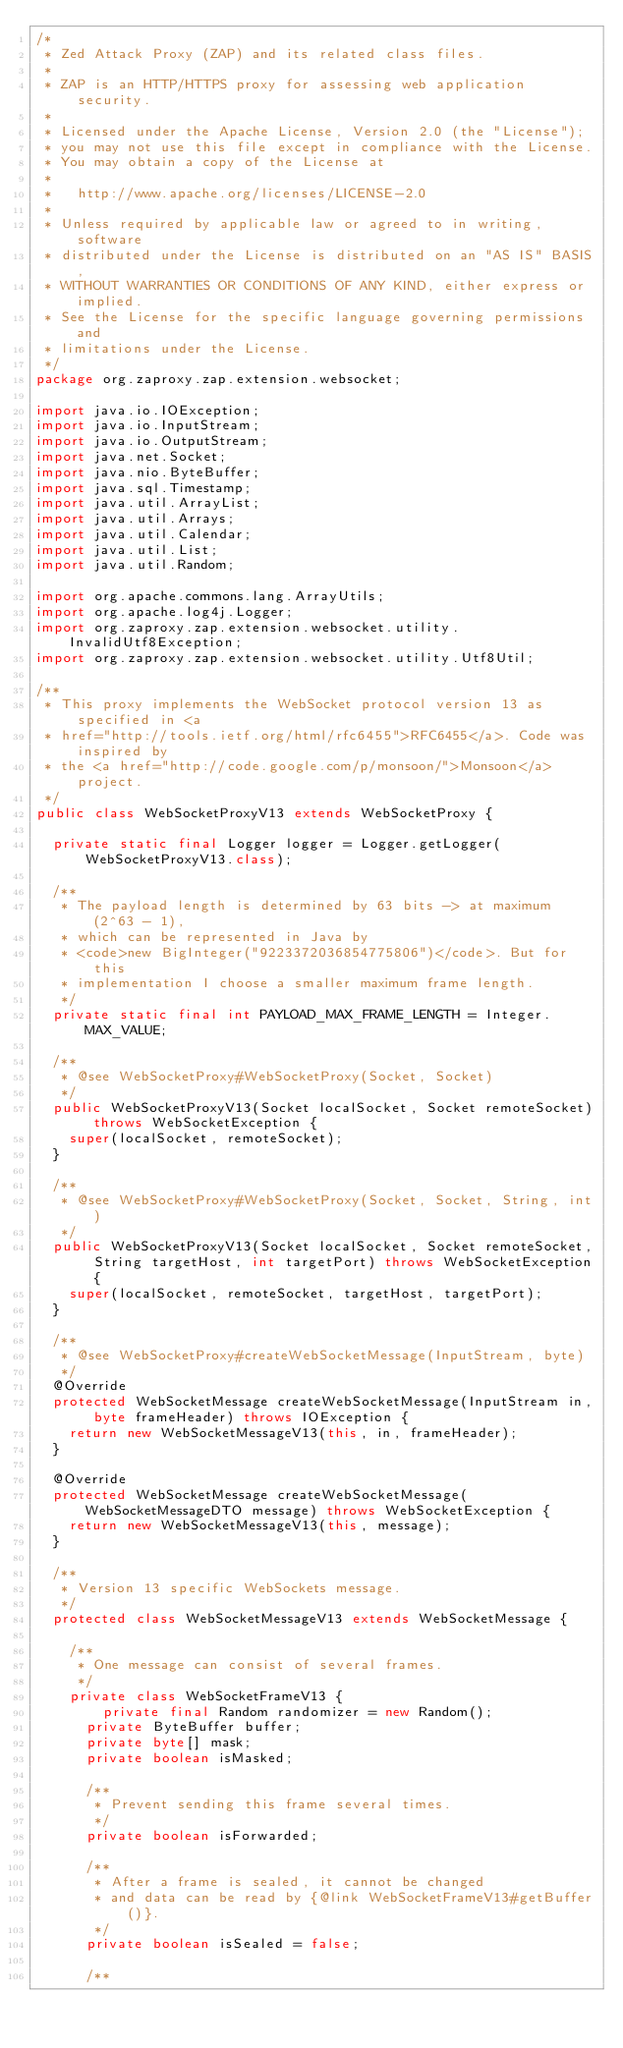Convert code to text. <code><loc_0><loc_0><loc_500><loc_500><_Java_>/*
 * Zed Attack Proxy (ZAP) and its related class files.
 * 
 * ZAP is an HTTP/HTTPS proxy for assessing web application security.
 * 
 * Licensed under the Apache License, Version 2.0 (the "License"); 
 * you may not use this file except in compliance with the License. 
 * You may obtain a copy of the License at 
 * 
 *   http://www.apache.org/licenses/LICENSE-2.0 
 *   
 * Unless required by applicable law or agreed to in writing, software 
 * distributed under the License is distributed on an "AS IS" BASIS, 
 * WITHOUT WARRANTIES OR CONDITIONS OF ANY KIND, either express or implied. 
 * See the License for the specific language governing permissions and 
 * limitations under the License. 
 */
package org.zaproxy.zap.extension.websocket;

import java.io.IOException;
import java.io.InputStream;
import java.io.OutputStream;
import java.net.Socket;
import java.nio.ByteBuffer;
import java.sql.Timestamp;
import java.util.ArrayList;
import java.util.Arrays;
import java.util.Calendar;
import java.util.List;
import java.util.Random;

import org.apache.commons.lang.ArrayUtils;
import org.apache.log4j.Logger;
import org.zaproxy.zap.extension.websocket.utility.InvalidUtf8Exception;
import org.zaproxy.zap.extension.websocket.utility.Utf8Util;

/**
 * This proxy implements the WebSocket protocol version 13 as specified in <a
 * href="http://tools.ietf.org/html/rfc6455">RFC6455</a>. Code was inspired by
 * the <a href="http://code.google.com/p/monsoon/">Monsoon</a> project.
 */
public class WebSocketProxyV13 extends WebSocketProxy {

	private static final Logger logger = Logger.getLogger(WebSocketProxyV13.class);
	
	/**
	 * The payload length is determined by 63 bits -> at maximum (2^63 - 1),
	 * which can be represented in Java by
	 * <code>new BigInteger("9223372036854775806")</code>. But for this
	 * implementation I choose a smaller maximum frame length.
	 */
	private static final int PAYLOAD_MAX_FRAME_LENGTH = Integer.MAX_VALUE;

	/**
	 * @see WebSocketProxy#WebSocketProxy(Socket, Socket)
	 */
	public WebSocketProxyV13(Socket localSocket, Socket remoteSocket) throws WebSocketException {
		super(localSocket, remoteSocket);
	}

	/**
	 * @see WebSocketProxy#WebSocketProxy(Socket, Socket, String, int)
	 */
	public WebSocketProxyV13(Socket localSocket, Socket remoteSocket, String targetHost, int targetPort) throws WebSocketException {
		super(localSocket, remoteSocket, targetHost, targetPort);
	}

	/**
	 * @see WebSocketProxy#createWebSocketMessage(InputStream, byte)
	 */
	@Override
	protected WebSocketMessage createWebSocketMessage(InputStream in, byte frameHeader) throws IOException {
		return new WebSocketMessageV13(this, in, frameHeader);
	}

	@Override
	protected WebSocketMessage createWebSocketMessage(WebSocketMessageDTO message) throws WebSocketException {
		return new WebSocketMessageV13(this, message);
	}

	/**
	 * Version 13 specific WebSockets message.
	 */
	protected class WebSocketMessageV13 extends WebSocketMessage {
		
		/**
		 * One message can consist of several frames.
		 */
		private class WebSocketFrameV13 {
		    private final Random randomizer = new Random();
			private ByteBuffer buffer;
			private byte[] mask;
			private boolean isMasked;
			
			/**
			 * Prevent sending this frame several times.
			 */
			private boolean isForwarded;

			/**
			 * After a frame is sealed, it cannot be changed
			 * and data can be read by {@link WebSocketFrameV13#getBuffer()}.
			 */
			private boolean isSealed = false;
			
			/**</code> 